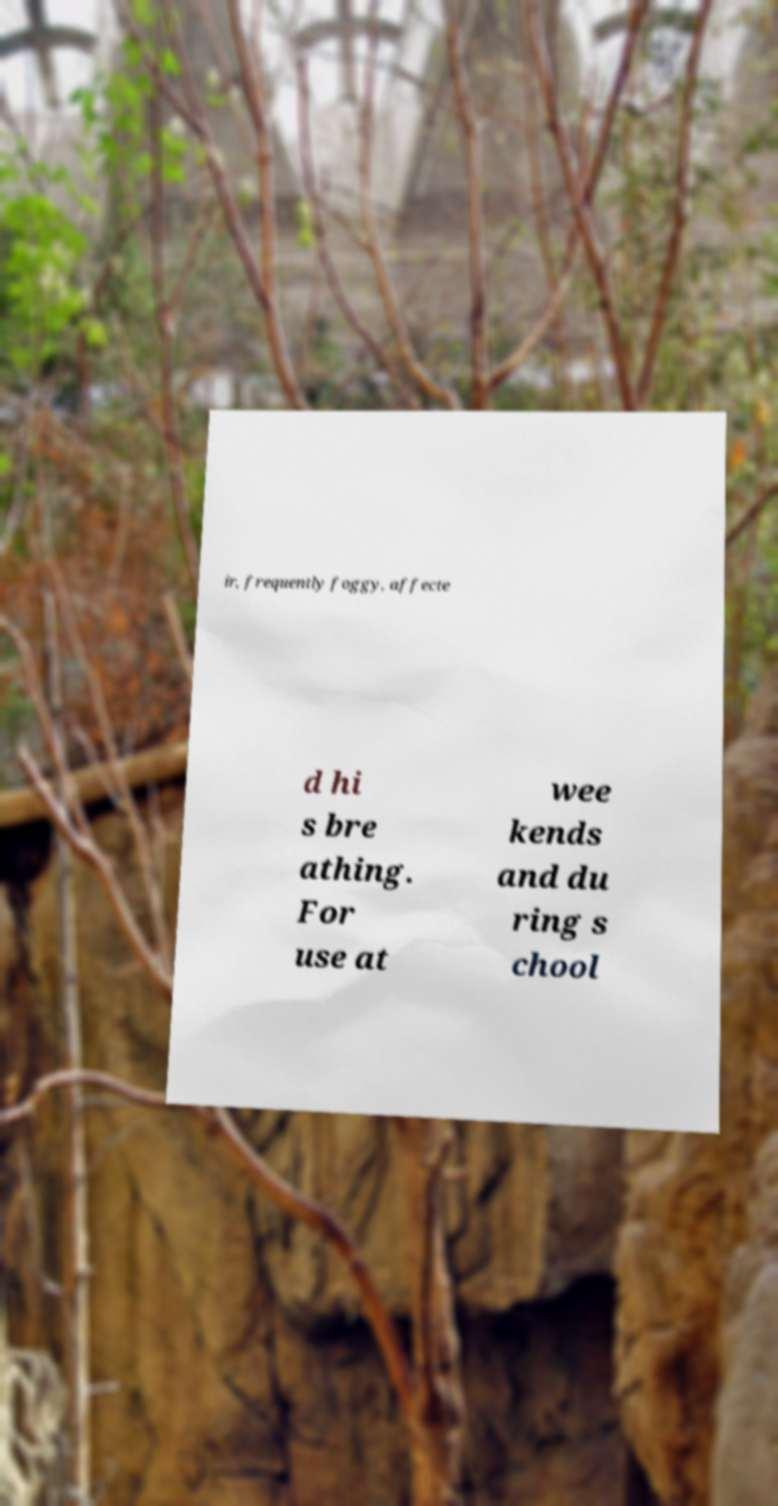Can you read and provide the text displayed in the image?This photo seems to have some interesting text. Can you extract and type it out for me? ir, frequently foggy, affecte d hi s bre athing. For use at wee kends and du ring s chool 